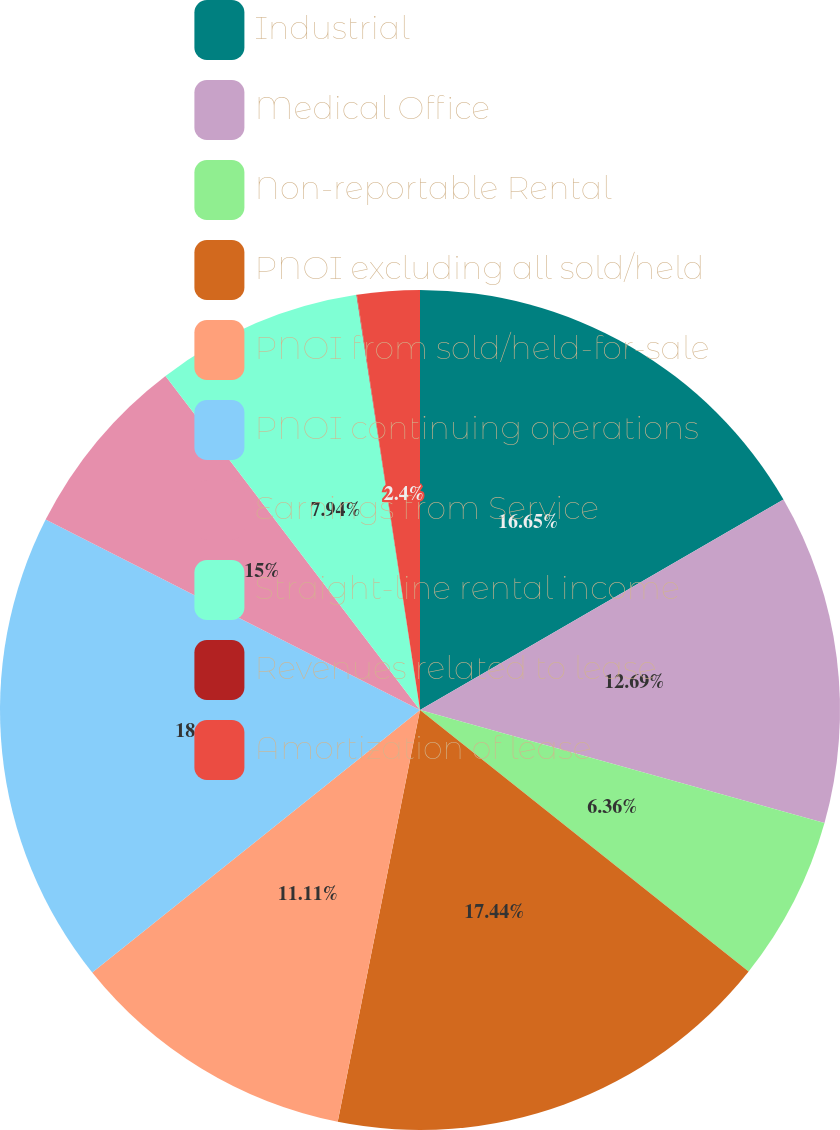Convert chart to OTSL. <chart><loc_0><loc_0><loc_500><loc_500><pie_chart><fcel>Industrial<fcel>Medical Office<fcel>Non-reportable Rental<fcel>PNOI excluding all sold/held<fcel>PNOI from sold/held-for-sale<fcel>PNOI continuing operations<fcel>Earnings from Service<fcel>Straight-line rental income<fcel>Revenues related to lease<fcel>Amortization of lease<nl><fcel>16.65%<fcel>12.69%<fcel>6.36%<fcel>17.44%<fcel>11.11%<fcel>18.24%<fcel>7.15%<fcel>7.94%<fcel>0.02%<fcel>2.4%<nl></chart> 